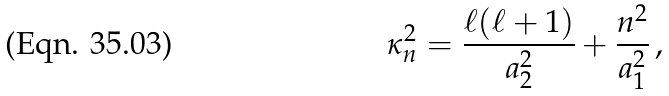<formula> <loc_0><loc_0><loc_500><loc_500>\kappa ^ { 2 } _ { n } = \frac { \ell ( \ell + 1 ) } { a ^ { 2 } _ { 2 } } + \frac { n ^ { 2 } } { a ^ { 2 } _ { 1 } } \, ,</formula> 